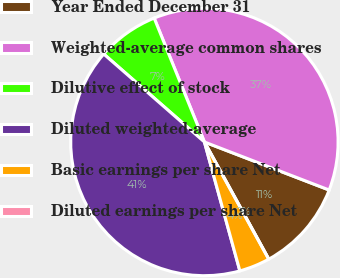<chart> <loc_0><loc_0><loc_500><loc_500><pie_chart><fcel>Year Ended December 31<fcel>Weighted-average common shares<fcel>Dilutive effect of stock<fcel>Diluted weighted-average<fcel>Basic earnings per share Net<fcel>Diluted earnings per share Net<nl><fcel>11.16%<fcel>36.98%<fcel>7.44%<fcel>40.7%<fcel>3.72%<fcel>0.0%<nl></chart> 